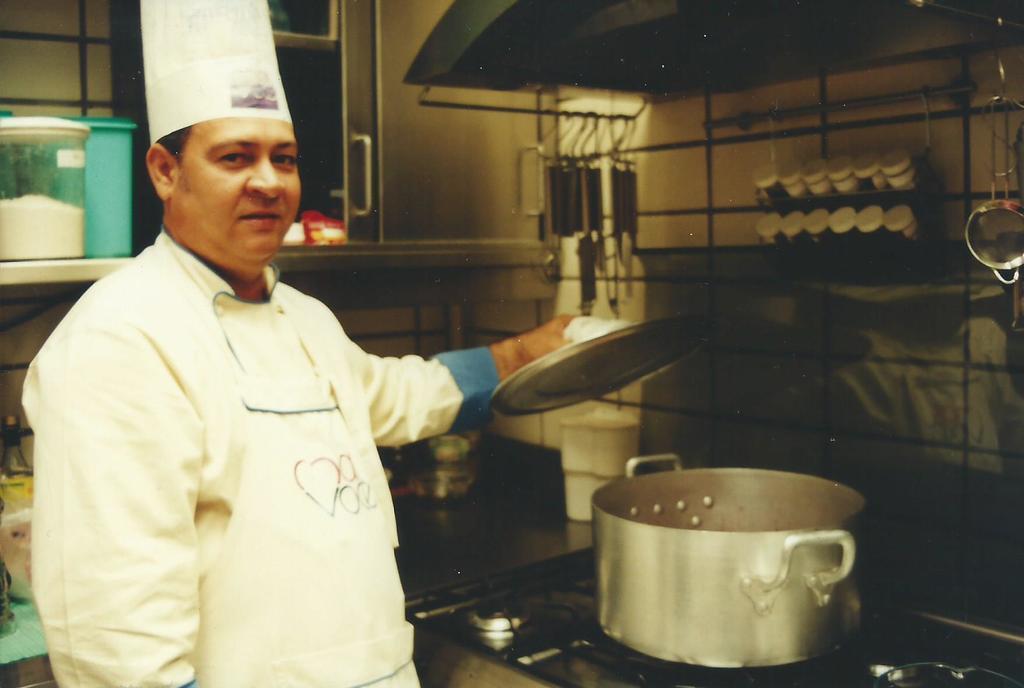Describe this image in one or two sentences. In this picture we can see a person holding a plate in his hand. We can see a vessel on the gas stove. There are a few boxes in the shelves. Few spoons are visible in racks. We can see other objects on a black surface. 